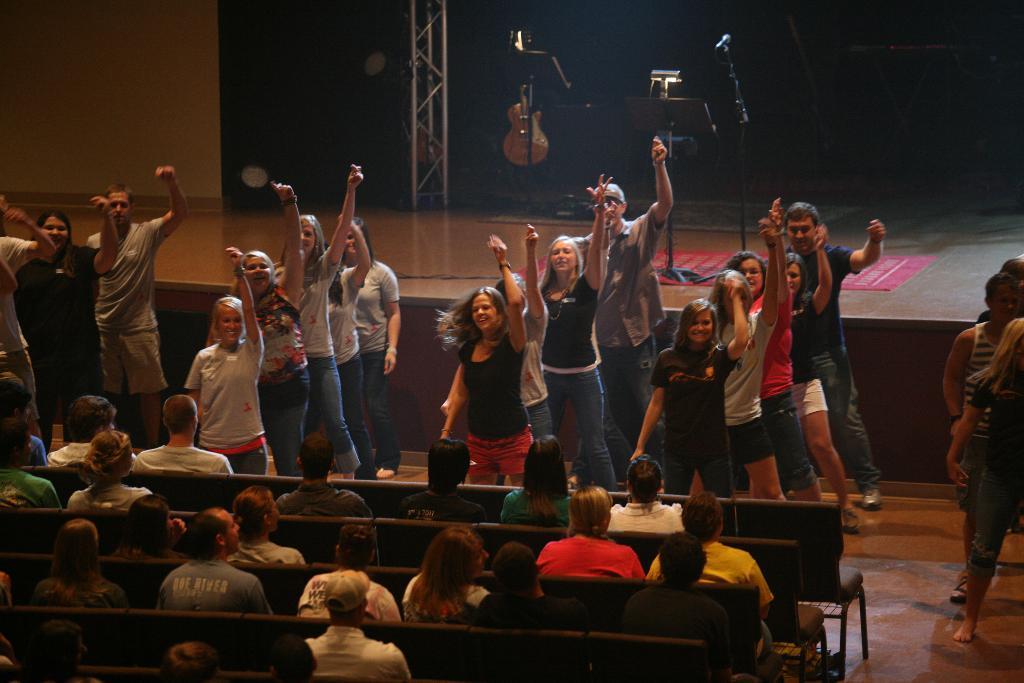In one or two sentences, can you explain what this image depicts? In this image there are people sitting on chairs, in the background few are dancing and there is a stage, on that stage there are musical instruments and there is a wall. 